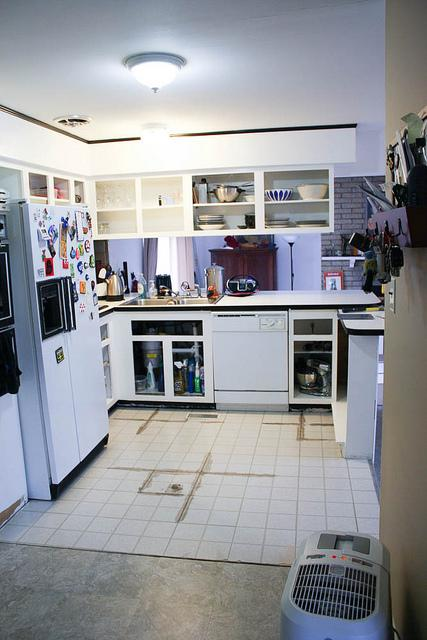What type of floor has been laid in the kitchen? tile 